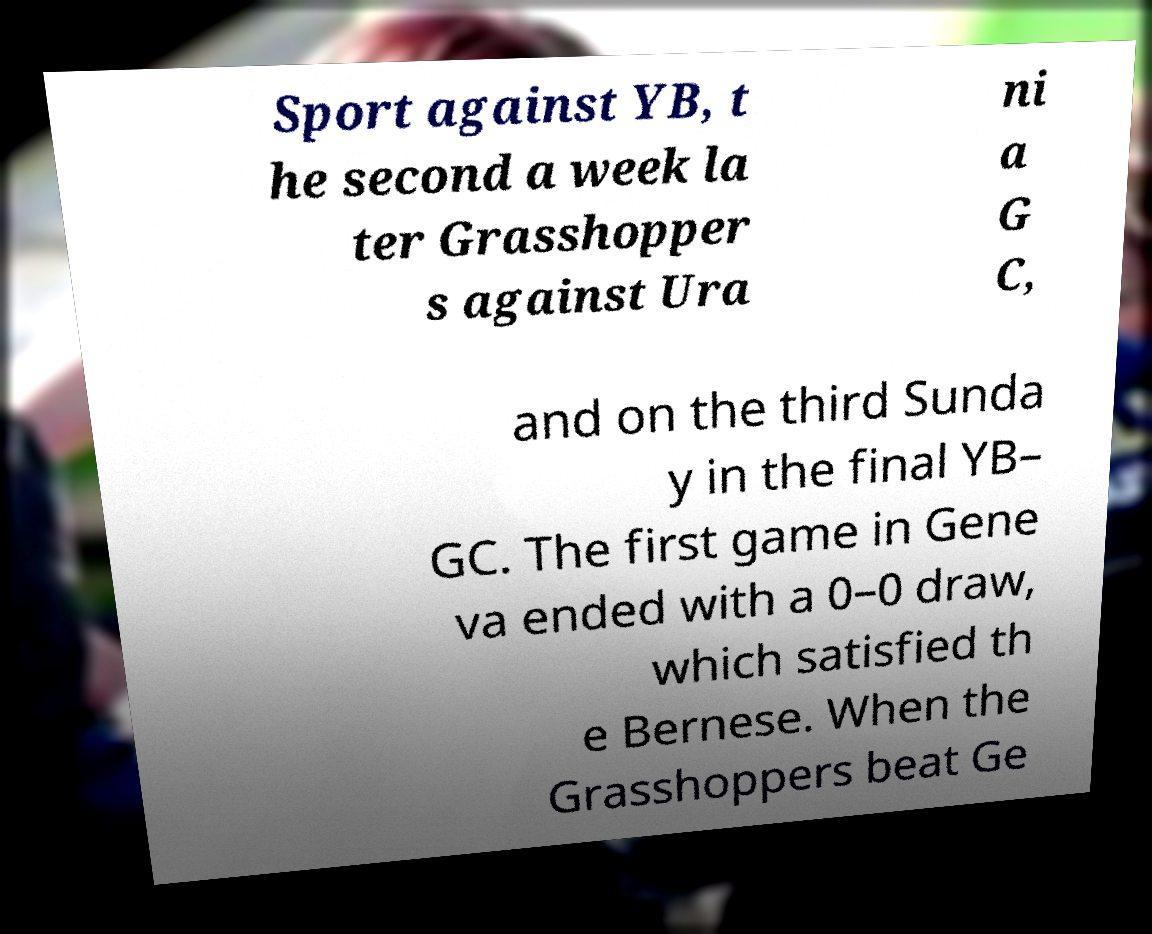Please read and relay the text visible in this image. What does it say? Sport against YB, t he second a week la ter Grasshopper s against Ura ni a G C, and on the third Sunda y in the final YB– GC. The first game in Gene va ended with a 0–0 draw, which satisfied th e Bernese. When the Grasshoppers beat Ge 